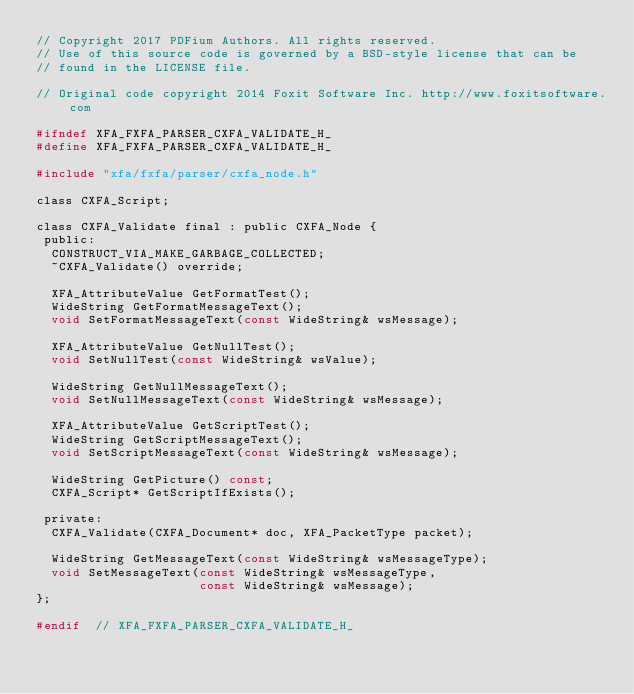Convert code to text. <code><loc_0><loc_0><loc_500><loc_500><_C_>// Copyright 2017 PDFium Authors. All rights reserved.
// Use of this source code is governed by a BSD-style license that can be
// found in the LICENSE file.

// Original code copyright 2014 Foxit Software Inc. http://www.foxitsoftware.com

#ifndef XFA_FXFA_PARSER_CXFA_VALIDATE_H_
#define XFA_FXFA_PARSER_CXFA_VALIDATE_H_

#include "xfa/fxfa/parser/cxfa_node.h"

class CXFA_Script;

class CXFA_Validate final : public CXFA_Node {
 public:
  CONSTRUCT_VIA_MAKE_GARBAGE_COLLECTED;
  ~CXFA_Validate() override;

  XFA_AttributeValue GetFormatTest();
  WideString GetFormatMessageText();
  void SetFormatMessageText(const WideString& wsMessage);

  XFA_AttributeValue GetNullTest();
  void SetNullTest(const WideString& wsValue);

  WideString GetNullMessageText();
  void SetNullMessageText(const WideString& wsMessage);

  XFA_AttributeValue GetScriptTest();
  WideString GetScriptMessageText();
  void SetScriptMessageText(const WideString& wsMessage);

  WideString GetPicture() const;
  CXFA_Script* GetScriptIfExists();

 private:
  CXFA_Validate(CXFA_Document* doc, XFA_PacketType packet);

  WideString GetMessageText(const WideString& wsMessageType);
  void SetMessageText(const WideString& wsMessageType,
                      const WideString& wsMessage);
};

#endif  // XFA_FXFA_PARSER_CXFA_VALIDATE_H_
</code> 